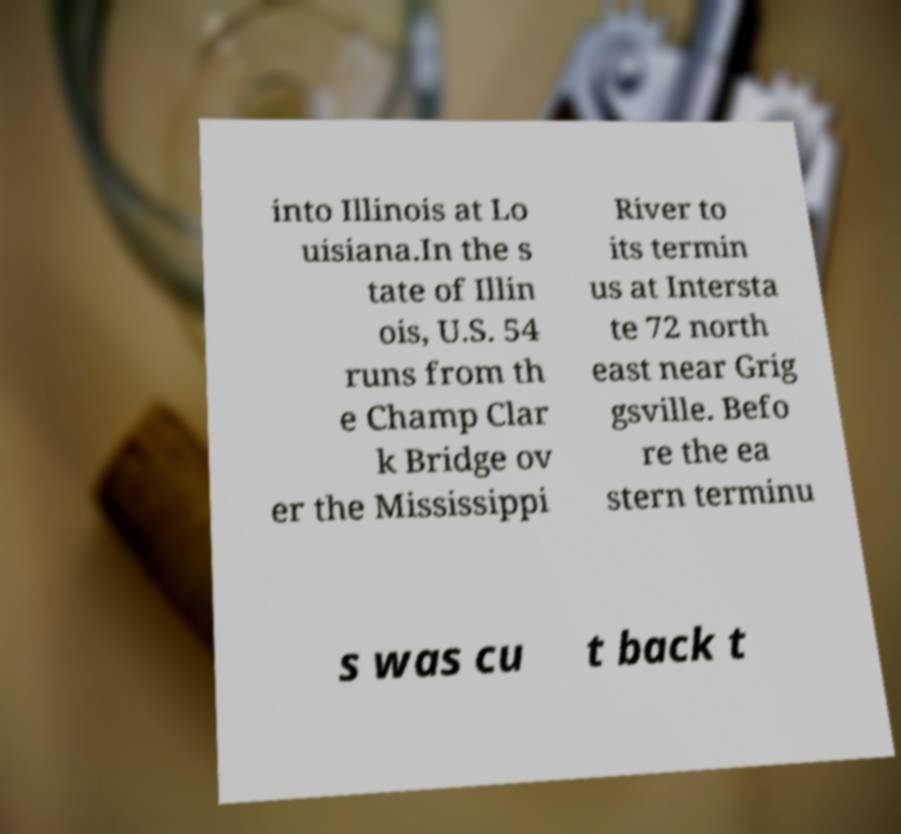Please read and relay the text visible in this image. What does it say? into Illinois at Lo uisiana.In the s tate of Illin ois, U.S. 54 runs from th e Champ Clar k Bridge ov er the Mississippi River to its termin us at Intersta te 72 north east near Grig gsville. Befo re the ea stern terminu s was cu t back t 